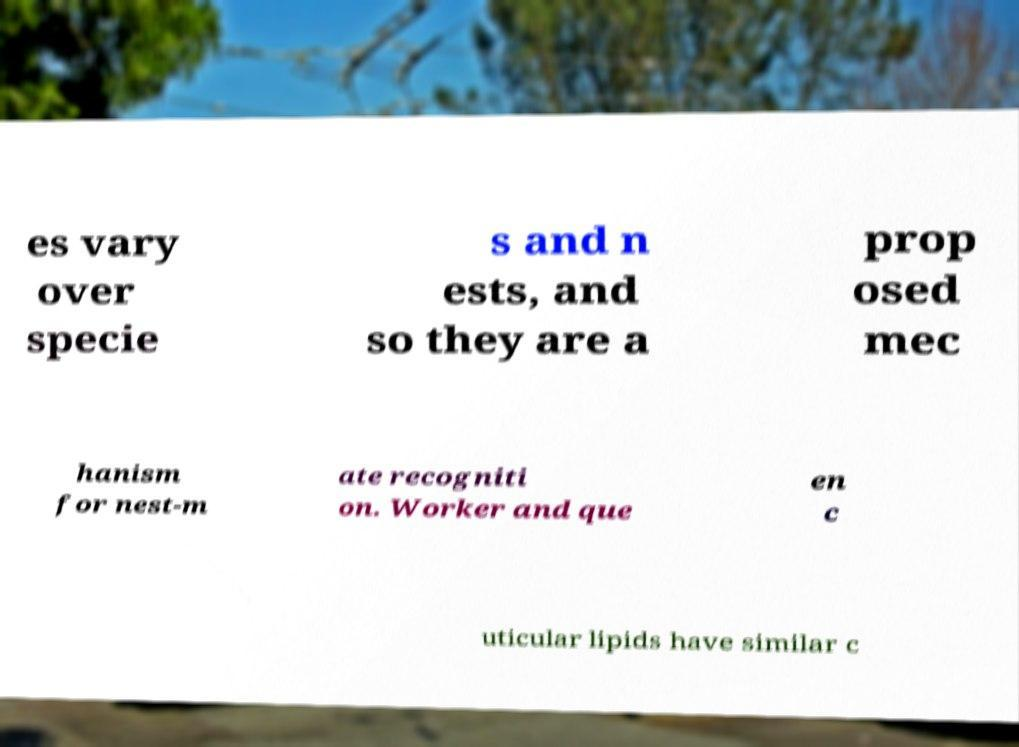What messages or text are displayed in this image? I need them in a readable, typed format. es vary over specie s and n ests, and so they are a prop osed mec hanism for nest-m ate recogniti on. Worker and que en c uticular lipids have similar c 